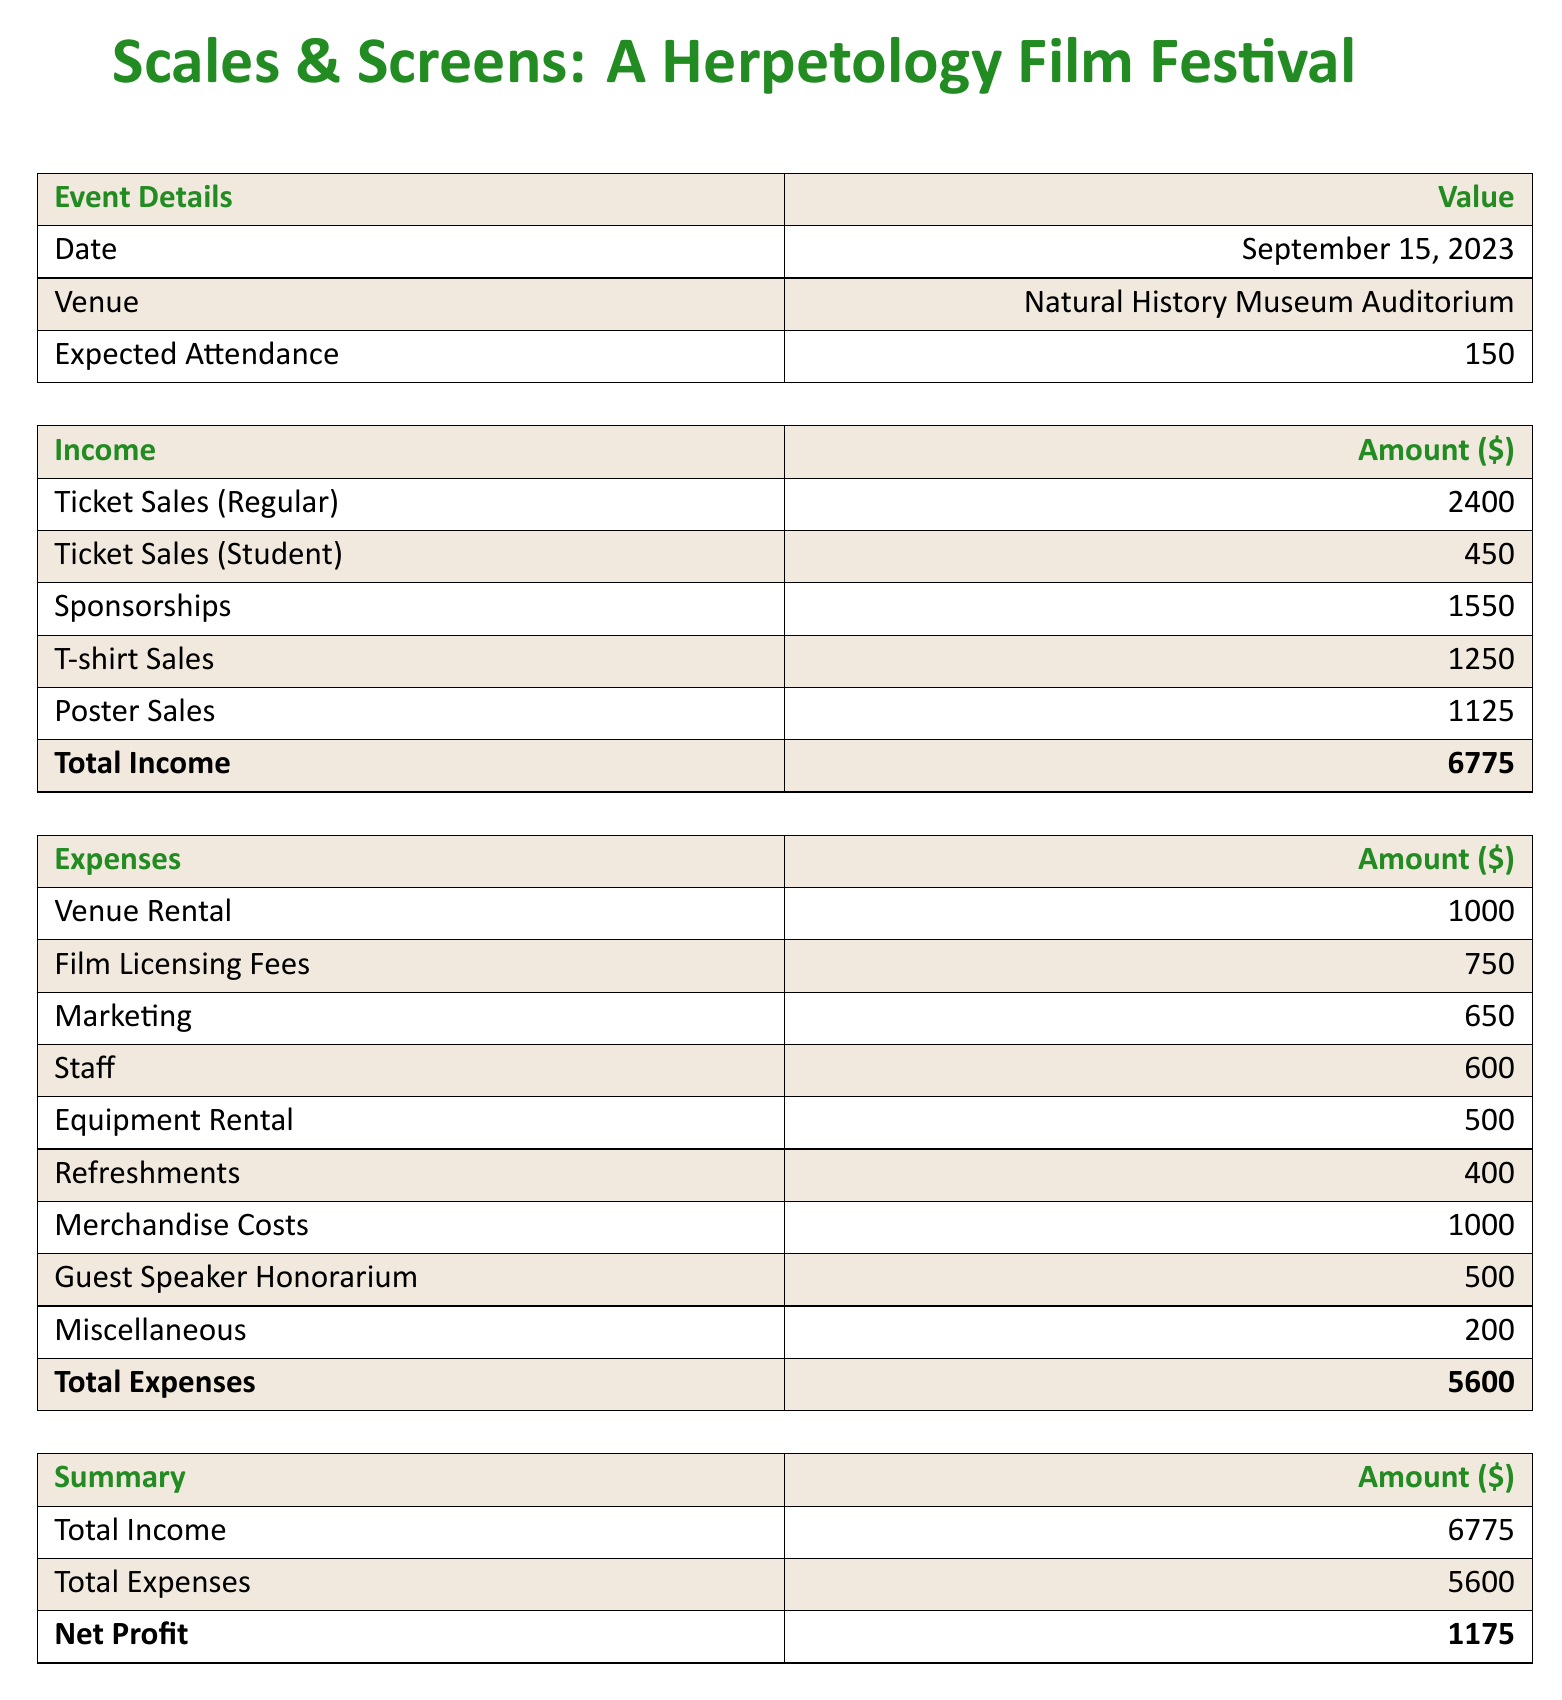What is the total income? The total income is summarized in the document as the sum of all income sources, which equals $2400 + $450 + $1550 + $1250 + $1125.
Answer: $6775 What is the expected attendance? The expected attendance for the event is explicitly stated in the document.
Answer: 150 What are the film licensing fees? The document details the expenses, and the film licensing fees are listed specifically as one of the items.
Answer: $750 What is the amount spent on marketing? The document provides a breakdown of expenses, where marketing costs are listed.
Answer: $650 What is the net profit from the event? The net profit is calculated by subtracting total expenses from total income, which is provided in the summary section.
Answer: $1175 What is the date of the event? The date of the event is stated near the top of the document under "Event Details."
Answer: September 15, 2023 What item has the highest associated cost? The expenses section lists various items, and the one with the highest cost is highlighted.
Answer: Venue Rental What is the total expenses amount? The total expenses are clearly summarized at the bottom of the expenses table.
Answer: $5600 How much revenue was generated from T-shirt sales? The income section specifies the revenue made from T-shirt sales as a separate item.
Answer: $1250 Who is receiving the guest speaker honorarium? The document includes an expense that mentions a guest speaker honorarium, but does not specify a name, only the amount.
Answer: $500 